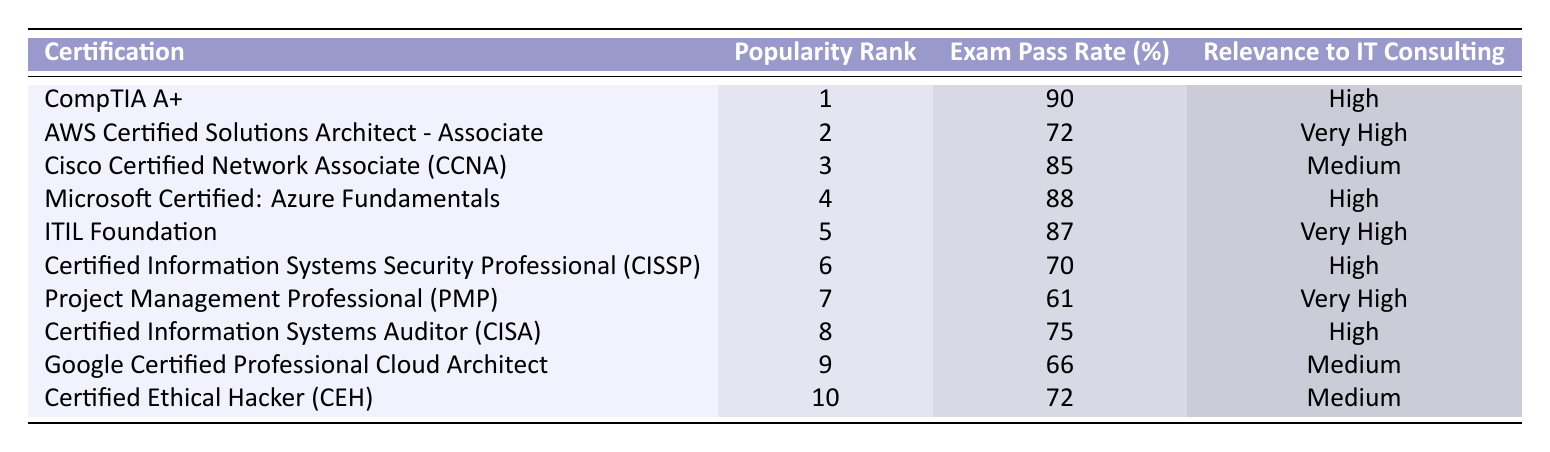What is the highest exam pass rate among the certifications? The table shows various certifications along with their exam pass rates. The highest pass rate is listed for CompTIA A+, which has a pass rate of 90%.
Answer: 90% Which certification has a medium relevance to IT consulting? The table lists certifications along with their relevance to IT consulting. Among the certifications marked with medium relevance, the Cisco Certified Network Associate (CCNA), Google Certified Professional Cloud Architect, and Certified Ethical Hacker (CEH) fall into this category.
Answer: Cisco Certified Network Associate (CCNA), Google Certified Professional Cloud Architect, Certified Ethical Hacker (CEH) What is the average exam pass rate of the top three certifications? The three certifications are CompTIA A+ (90%), AWS Certified Solutions Architect - Associate (72%), and Cisco Certified Network Associate (CCNA) (85%). The sum of their pass rates is 90 + 72 + 85 = 247. To find the average, divide by 3: 247 / 3 = 82.33.
Answer: 82.33% Is it true that the Project Management Professional (PMP) has a higher pass rate than the Certified Information Systems Auditor (CISA)? The pass rate for PMP is 61%, while CISA has a pass rate of 75%. Since 61% is less than 75%, the statement is false.
Answer: No What is the difference in exam pass rates between the CompTIA A+ and the AWS Certified Solutions Architect - Associate? CompTIA A+ has a pass rate of 90% and AWS Certified Solutions Architect - Associate has a pass rate of 72%. To find the difference, subtract the latter from the former: 90 - 72 = 18.
Answer: 18% Which certification ranked fifth in popularity has a very high relevance to IT consulting? According to the table, the certification that ranked fifth is ITIL Foundation and it has a relevance rating of very high.
Answer: ITIL Foundation What is the most popular certification that has a lower pass rate than the Certified Information Systems Security Professional (CISSP)? The CISSP has a pass rate of 70%. The certifications with a lower pass rate include Project Management Professional (PMP) (61%) and Google Certified Professional Cloud Architect (66%). Among those, PMP is the most popular based on ranking (7).
Answer: Project Management Professional (PMP) How many certifications have a pass rate above 80%? Examining the table, CompTIA A+ (90%), Cisco Certified Network Associate (CCNA) (85%), Microsoft Certified: Azure Fundamentals (88%), and ITIL Foundation (87%) have pass rates above 80%. This totals to 4 certifications.
Answer: 4 What certification has the lowest exam pass rate and what is that rate? From the table, the certification with the lowest pass rate is Project Management Professional (PMP) with a pass rate of 61%.
Answer: 61% 